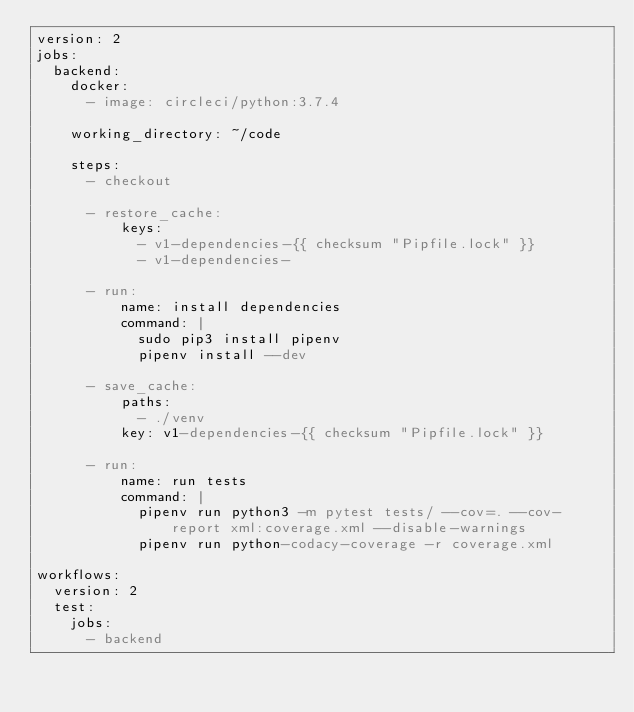Convert code to text. <code><loc_0><loc_0><loc_500><loc_500><_YAML_>version: 2
jobs:
  backend:
    docker:
      - image: circleci/python:3.7.4

    working_directory: ~/code

    steps:
      - checkout

      - restore_cache:
          keys:
            - v1-dependencies-{{ checksum "Pipfile.lock" }}
            - v1-dependencies-

      - run:
          name: install dependencies
          command: |
            sudo pip3 install pipenv
            pipenv install --dev

      - save_cache:
          paths:
            - ./venv
          key: v1-dependencies-{{ checksum "Pipfile.lock" }}

      - run:
          name: run tests
          command: |
            pipenv run python3 -m pytest tests/ --cov=. --cov-report xml:coverage.xml --disable-warnings
            pipenv run python-codacy-coverage -r coverage.xml

workflows:
  version: 2
  test:
    jobs:
      - backend
</code> 